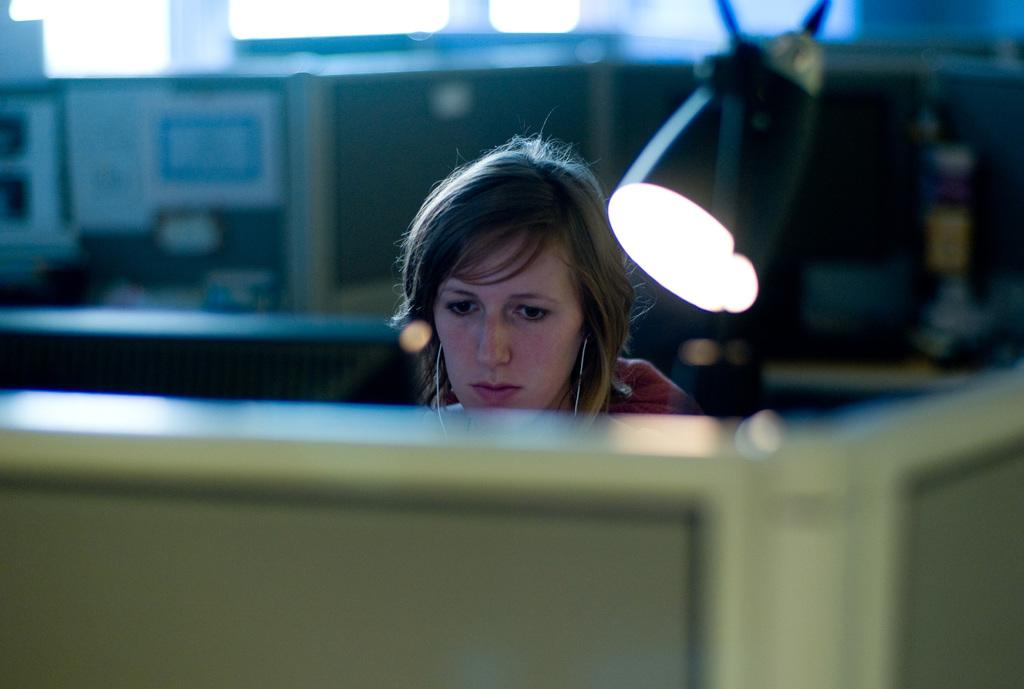Who is present in the image? There is a woman in the image. What object can be seen on the right side of the image? There is a lamp on the right side of the image. What type of structure is visible at the bottom of the image? There appears to be a cabin at the bottom of the image. Can you describe the background of the image? The background of the image is blurred. What type of field can be seen in the image? There is no field present in the image. 